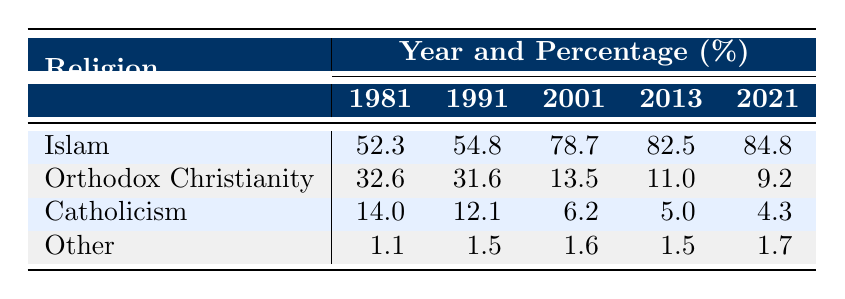What was the percentage of the Orthodox Christian population in Zenica in 2001? From the table, the percentage of Orthodox Christians in 2001 is listed directly under that year, which shows it is 13.5%.
Answer: 13.5 Which religion had the highest percentage of adherents in 2013? The table shows the percentages for each religion in 2013, with Islam at 82.5%, which is the highest compared to the other religions listed.
Answer: Islam What is the total percentage of the Orthodox Christian and Catholic populations combined in 2021? In 2021, the percentages for Orthodox Christianity and Catholicism are 9.2% and 4.3% respectively. Adding these gives 9.2 + 4.3 = 13.5%.
Answer: 13.5 Did the percentage of Catholicism increase from 1981 to 1991? By comparing the values in the table, Catholicism had a percentage of 14.0% in 1981 and decreased to 12.1% in 1991, indicating a decline.
Answer: No How much did the percentage of the Islamic population increase from 2001 to 2021? In 2001, the percentage of Islam was 78.7%, and in 2021 it was 84.8%. To find the increase, subtract 78.7 from 84.8, resulting in an increase of 6.1%.
Answer: 6.1 